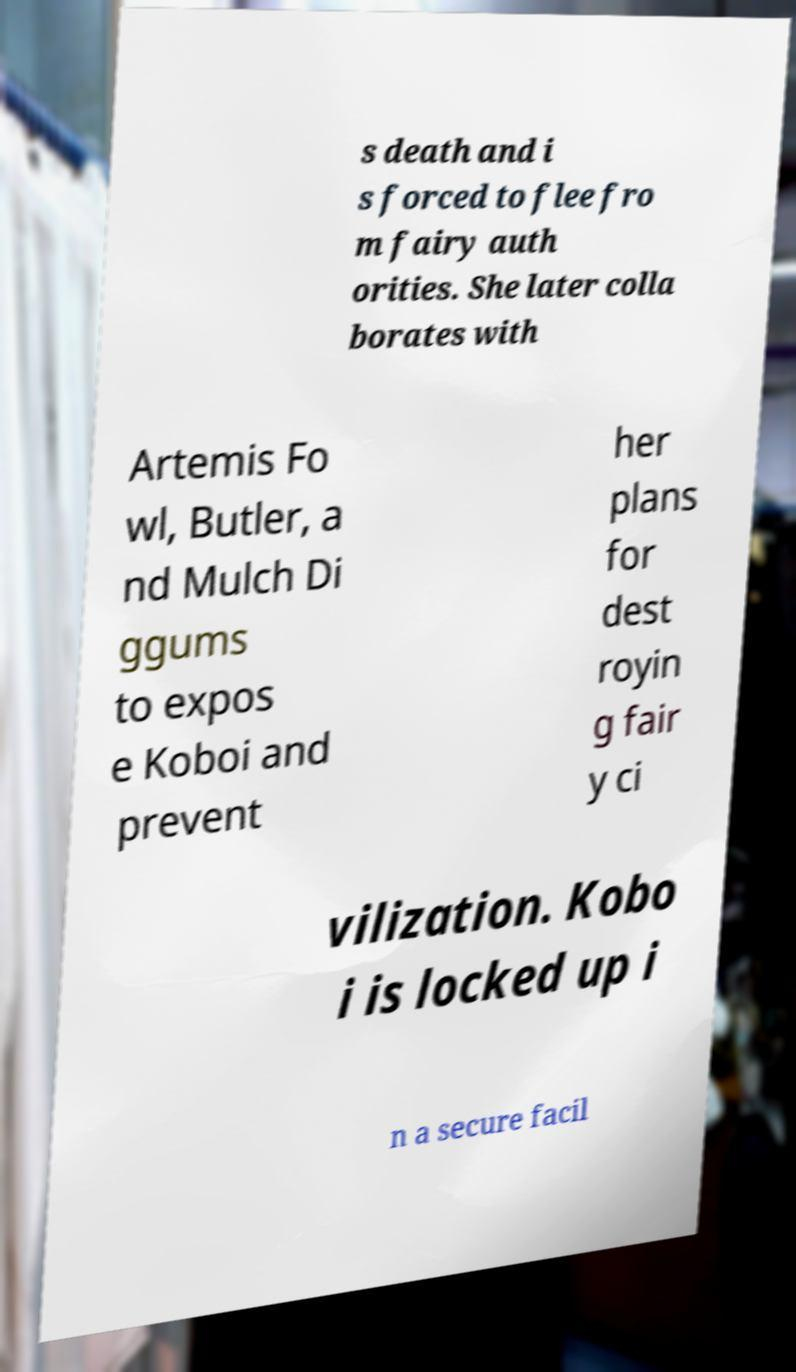Can you accurately transcribe the text from the provided image for me? s death and i s forced to flee fro m fairy auth orities. She later colla borates with Artemis Fo wl, Butler, a nd Mulch Di ggums to expos e Koboi and prevent her plans for dest royin g fair y ci vilization. Kobo i is locked up i n a secure facil 